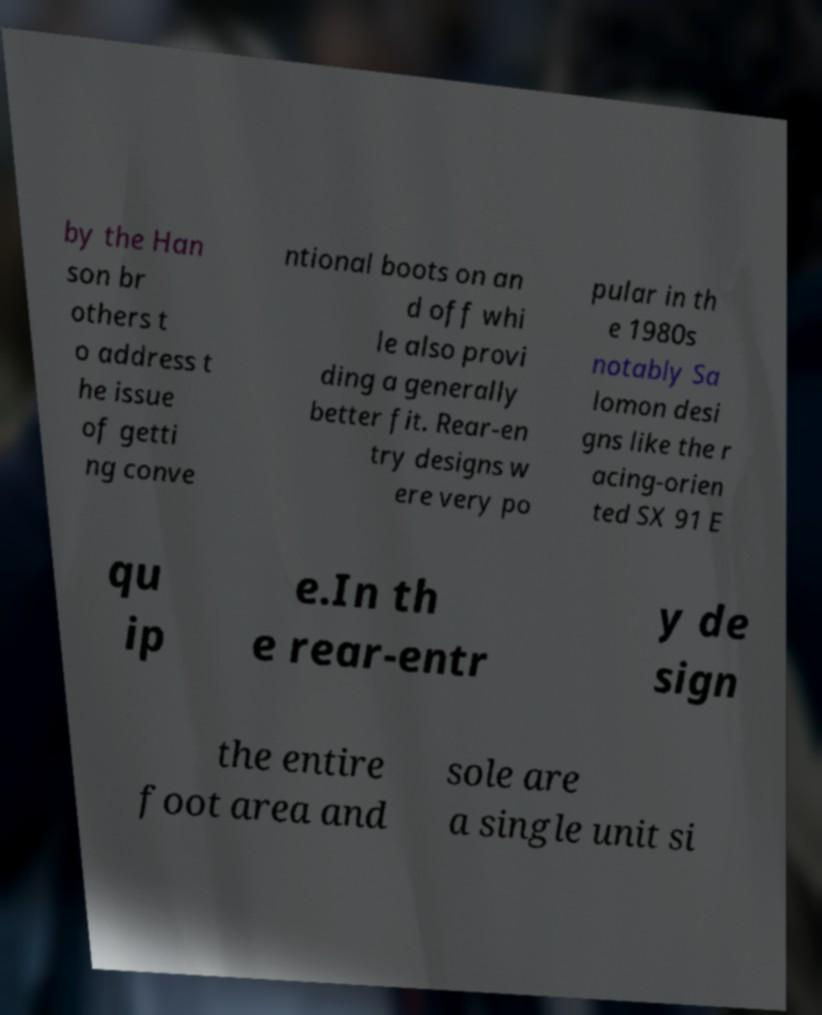Can you accurately transcribe the text from the provided image for me? by the Han son br others t o address t he issue of getti ng conve ntional boots on an d off whi le also provi ding a generally better fit. Rear-en try designs w ere very po pular in th e 1980s notably Sa lomon desi gns like the r acing-orien ted SX 91 E qu ip e.In th e rear-entr y de sign the entire foot area and sole are a single unit si 